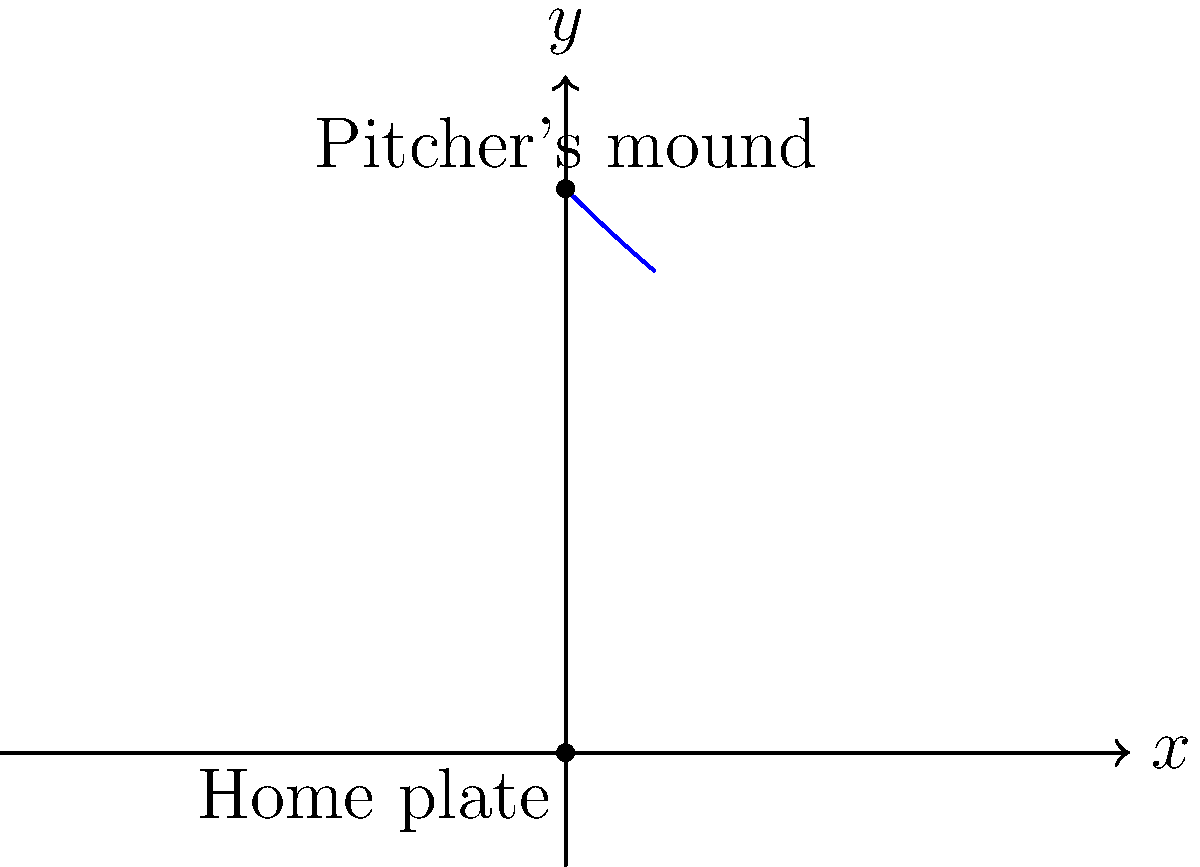In a baseball game, you're analyzing the path of a curveball thrown by the pitcher. The path can be modeled using the polar equation $r = 50e^{-0.02\theta}$, where $r$ is in feet and $\theta$ is in radians. The origin (0,0) represents home plate, and the pitcher's mound is 50 feet away on the y-axis. At what angle $\theta$ (in radians) does the ball cross home plate? To find the angle at which the ball crosses home plate, we need to follow these steps:

1) The ball crosses home plate when $r = 0$. So, we need to solve the equation:

   $0 = 50e^{-0.02\theta}$

2) Taking the natural log of both sides:

   $\ln(0) = \ln(50) - 0.02\theta$

3) $\ln(0)$ is undefined, but we can approach this problem by considering when $r$ is very close to 0.

4) As $r$ approaches 0, $\ln(r)$ approaches negative infinity. So, we need to find when:

   $-0.02\theta \to -\infty$

5) This happens as $\theta \to \infty$.

6) However, in a real baseball scenario, we need to consider a practical limit. The ball typically makes less than one full revolution before reaching home plate.

7) One full revolution would be $2\pi$ radians. We can see from the graph that the ball reaches home plate well before completing a full revolution.

8) A good estimate from the graph would be about $2.5\pi$ radians, or $5\pi/2$ radians.

Therefore, the ball crosses home plate at approximately $2.5\pi$ radians or $5\pi/2$ radians.
Answer: $\frac{5\pi}{2}$ radians 